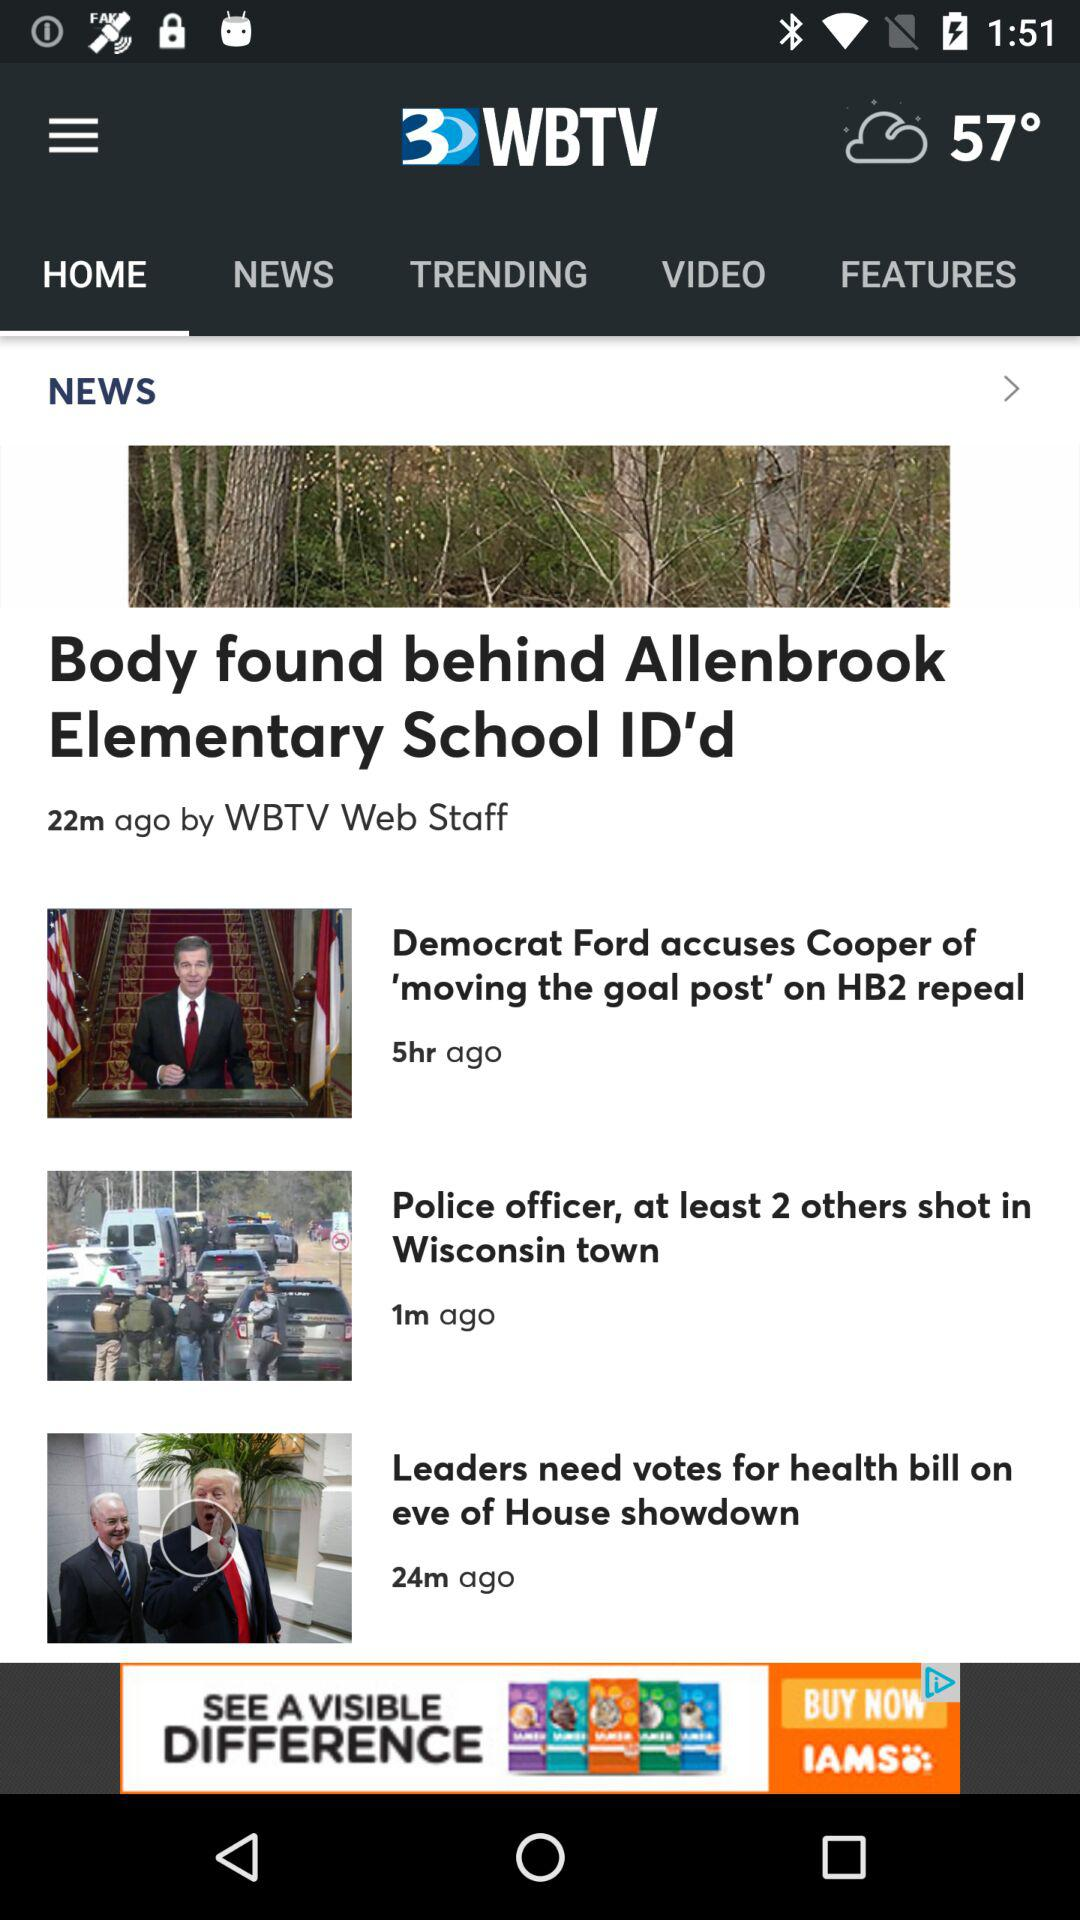Which tab am I using? You are using the "HOME" tab. 